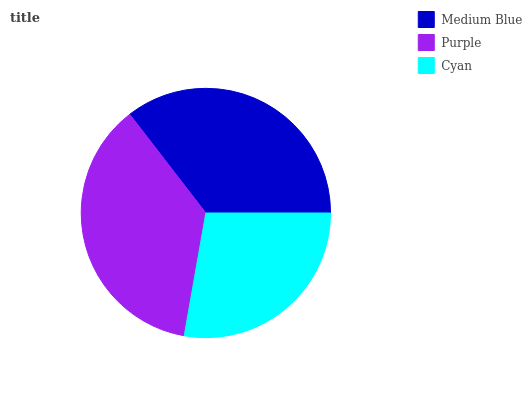Is Cyan the minimum?
Answer yes or no. Yes. Is Purple the maximum?
Answer yes or no. Yes. Is Purple the minimum?
Answer yes or no. No. Is Cyan the maximum?
Answer yes or no. No. Is Purple greater than Cyan?
Answer yes or no. Yes. Is Cyan less than Purple?
Answer yes or no. Yes. Is Cyan greater than Purple?
Answer yes or no. No. Is Purple less than Cyan?
Answer yes or no. No. Is Medium Blue the high median?
Answer yes or no. Yes. Is Medium Blue the low median?
Answer yes or no. Yes. Is Purple the high median?
Answer yes or no. No. Is Purple the low median?
Answer yes or no. No. 